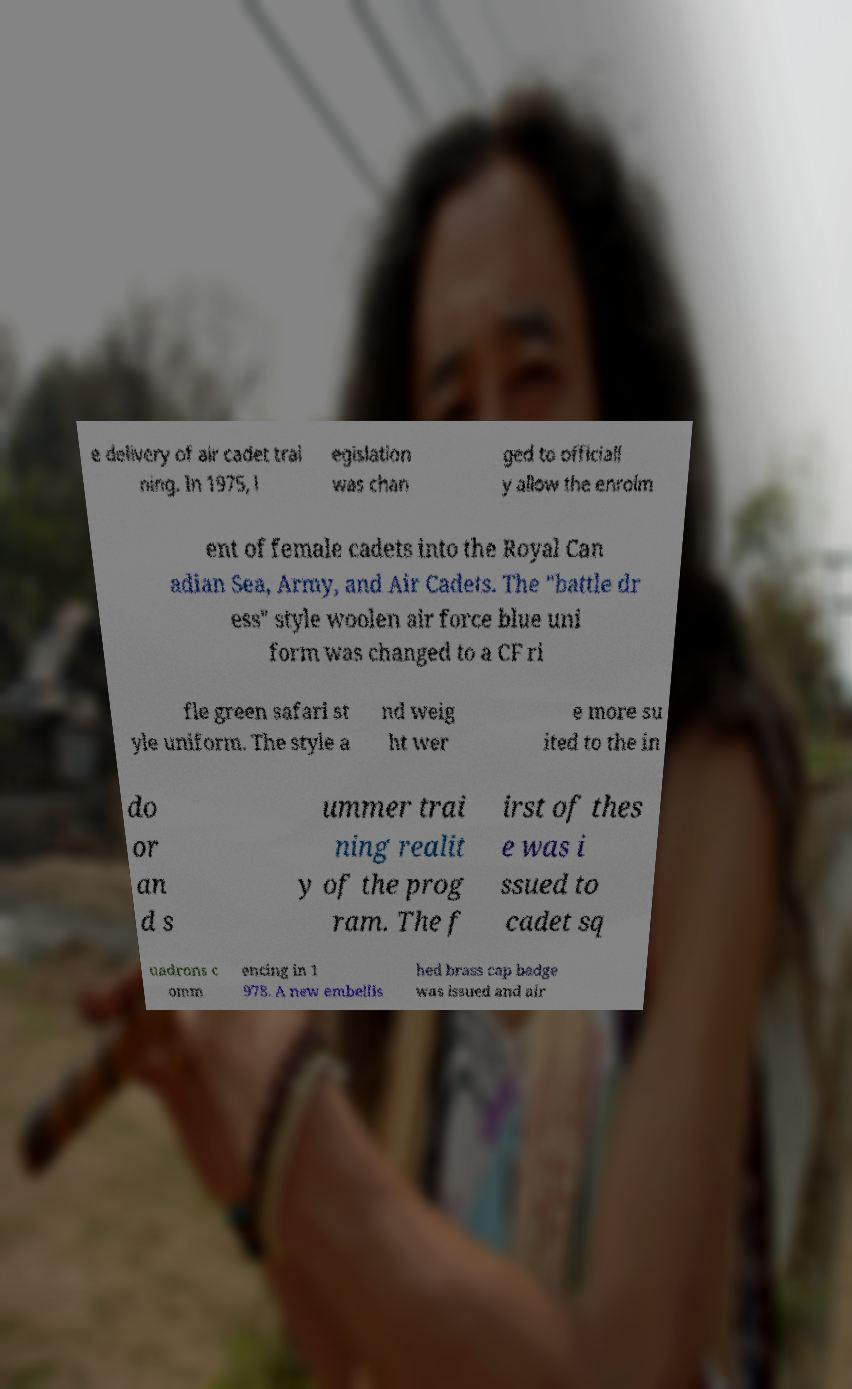What messages or text are displayed in this image? I need them in a readable, typed format. e delivery of air cadet trai ning. In 1975, l egislation was chan ged to officiall y allow the enrolm ent of female cadets into the Royal Can adian Sea, Army, and Air Cadets. The "battle dr ess" style woolen air force blue uni form was changed to a CF ri fle green safari st yle uniform. The style a nd weig ht wer e more su ited to the in do or an d s ummer trai ning realit y of the prog ram. The f irst of thes e was i ssued to cadet sq uadrons c omm encing in 1 978. A new embellis hed brass cap badge was issued and air 